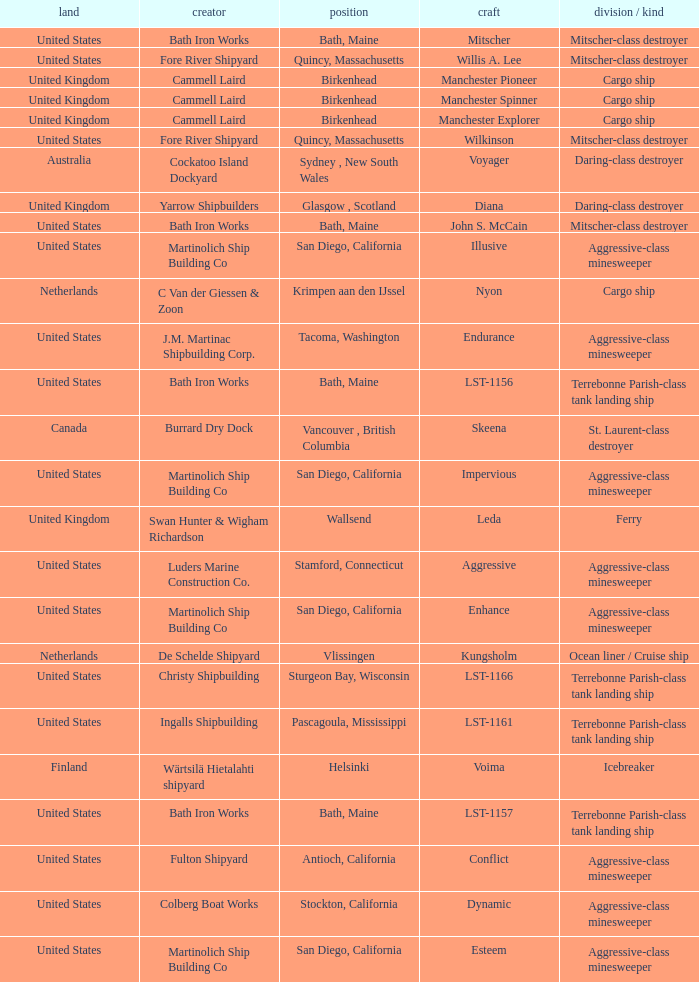What Ship was Built by Cammell Laird? Manchester Pioneer, Manchester Spinner, Manchester Explorer. 